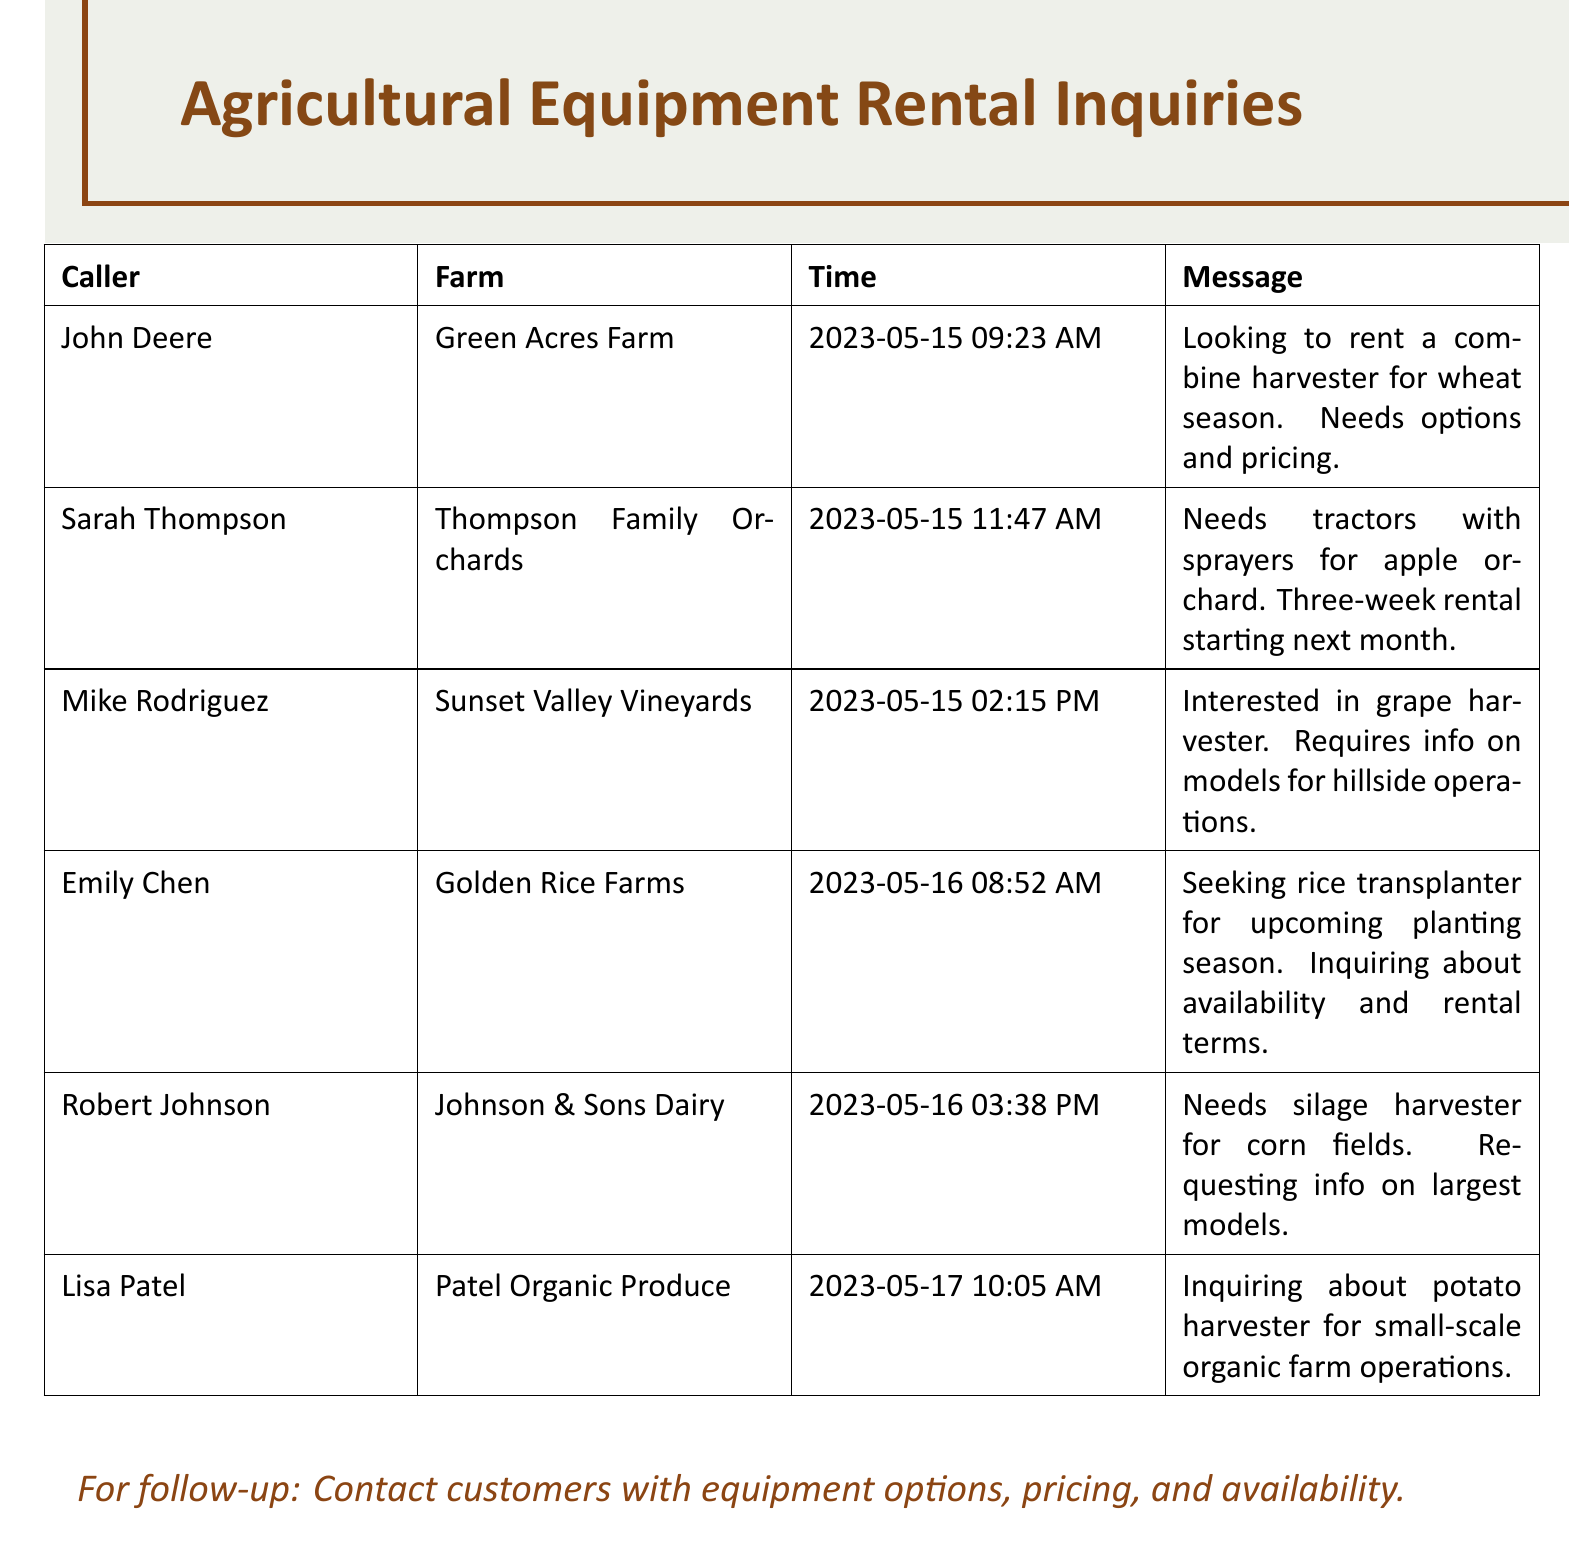What is the name of the caller who inquired about the combine harvester? The caller is John Deere, who requested information on a combine harvester for wheat season.
Answer: John Deere What date did Sarah Thompson leave her message? The date of the message was May 15, 2023, at 11:47 AM.
Answer: 2023-05-15 Which farm is associated with Emily Chen? Emily Chen is linked to Golden Rice Farms, where she is seeking a rice transplanter.
Answer: Golden Rice Farms What type of equipment does Mike Rodriguez want? Mike Rodriguez is interested in a grape harvester for hillside operations.
Answer: grape harvester How long does Sarah Thompson need the tractors for? Sarah Thompson needs the tractors for a three-week rental starting next month.
Answer: three weeks What is the focus of Lisa Patel's inquiry? Lisa Patel is inquiring about a potato harvester for small-scale organic farm operations.
Answer: potato harvester What time did Robert Johnson leave his message? Robert Johnson left his message at 3:38 PM on May 16, 2023.
Answer: 3:38 PM What information does Emily Chen want regarding the rice transplanter? Emily Chen is inquiring about availability and rental terms for the rice transplanter.
Answer: availability and rental terms How many total messages are included in the document? The document contains six messages from different callers.
Answer: six 